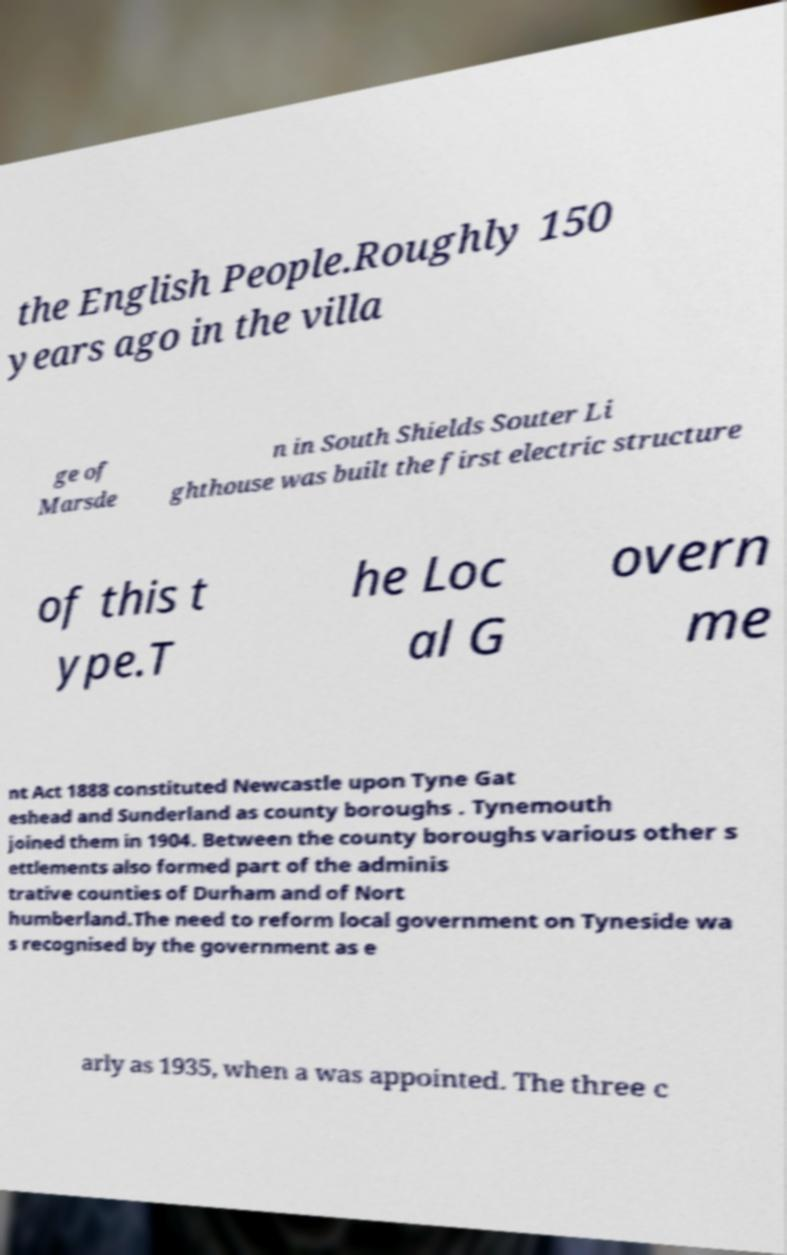Please identify and transcribe the text found in this image. the English People.Roughly 150 years ago in the villa ge of Marsde n in South Shields Souter Li ghthouse was built the first electric structure of this t ype.T he Loc al G overn me nt Act 1888 constituted Newcastle upon Tyne Gat eshead and Sunderland as county boroughs . Tynemouth joined them in 1904. Between the county boroughs various other s ettlements also formed part of the adminis trative counties of Durham and of Nort humberland.The need to reform local government on Tyneside wa s recognised by the government as e arly as 1935, when a was appointed. The three c 